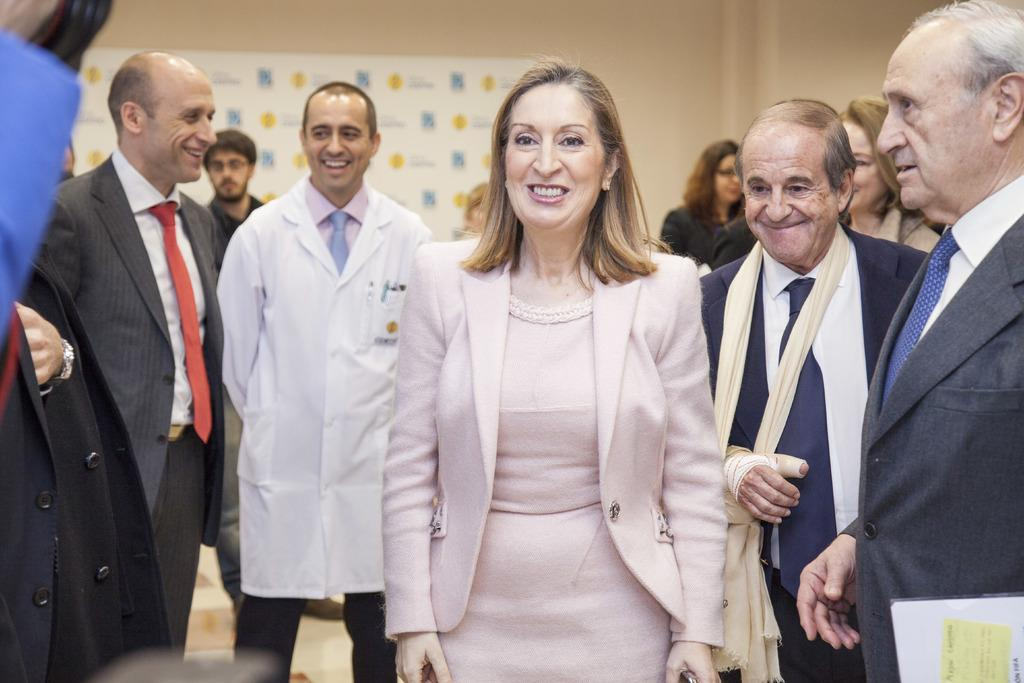What is happening in the image? There are persons standing in the image. Where are the persons standing? The persons are standing on the floor. What can be seen in the background of the image? There are advertisements on the wall in the background of the image. What type of furniture is being used by the persons in the image? There is no furniture visible in the image; the persons are standing on the floor. Are the persons sleeping in the image? No, the persons are standing in the image, not sleeping. 